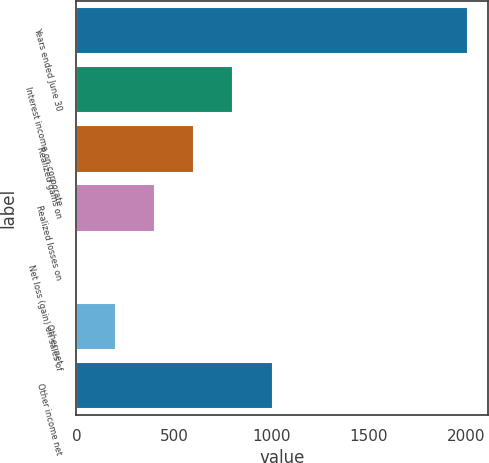Convert chart. <chart><loc_0><loc_0><loc_500><loc_500><bar_chart><fcel>Years ended June 30<fcel>Interest income on corporate<fcel>Realized gains on<fcel>Realized losses on<fcel>Net loss (gain) on sales of<fcel>Other net<fcel>Other income net<nl><fcel>2010<fcel>805.38<fcel>604.61<fcel>403.84<fcel>2.3<fcel>203.07<fcel>1006.15<nl></chart> 